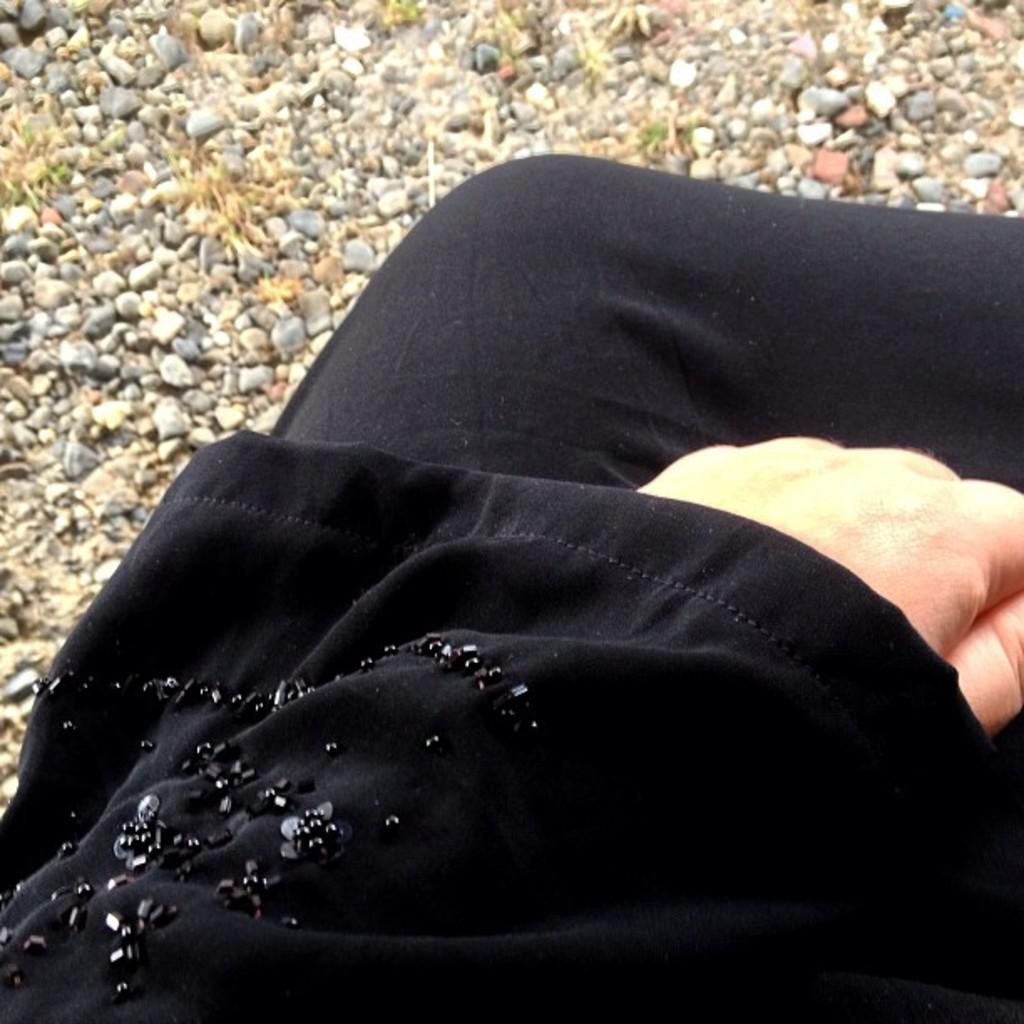What body parts of a person are visible in the image? There is a person's hand and legs in the center of the image. What can be seen in the background of the image? There are stones in the background of the image. What type of seed can be seen growing on the person's hand in the image? There is no seed present on the person's hand in the image. Is there a screw visible on the person's legs in the image? There is no screw present on the person's legs in the image. 